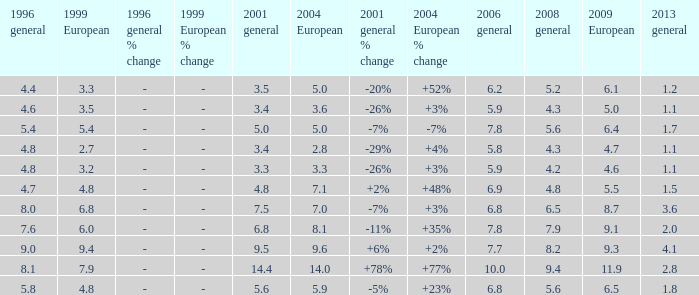What is the lowest value for 2004 European when 1999 European is 3.3 and less than 4.4 in 1996 general? None. 